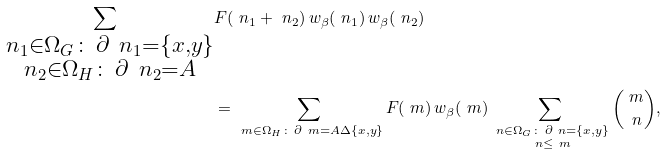Convert formula to latex. <formula><loc_0><loc_0><loc_500><loc_500>\sum _ { \substack { \ n _ { 1 } \in \Omega _ { G } \colon \, \partial \ n _ { 1 } = \{ x , y \} \\ \ n _ { 2 } \in \Omega _ { H } \colon \, \partial \ n _ { 2 } = A } } & F ( \ n _ { 1 } + \ n _ { 2 } ) \, w _ { \beta } ( \ n _ { 1 } ) \, w _ { \beta } ( \ n _ { 2 } ) \\ & = \sum _ { \substack { \ m \in \Omega _ { H } \colon \, \partial \ m = A \Delta \{ x , y \} } } F ( \ m ) \, w _ { \beta } ( \ m ) \sum _ { \substack { \ n \in \Omega _ { G } \colon \, \partial \ n = \{ x , y \} \\ \ n \leq \ m } } \binom { \ m } { \ n } ,</formula> 